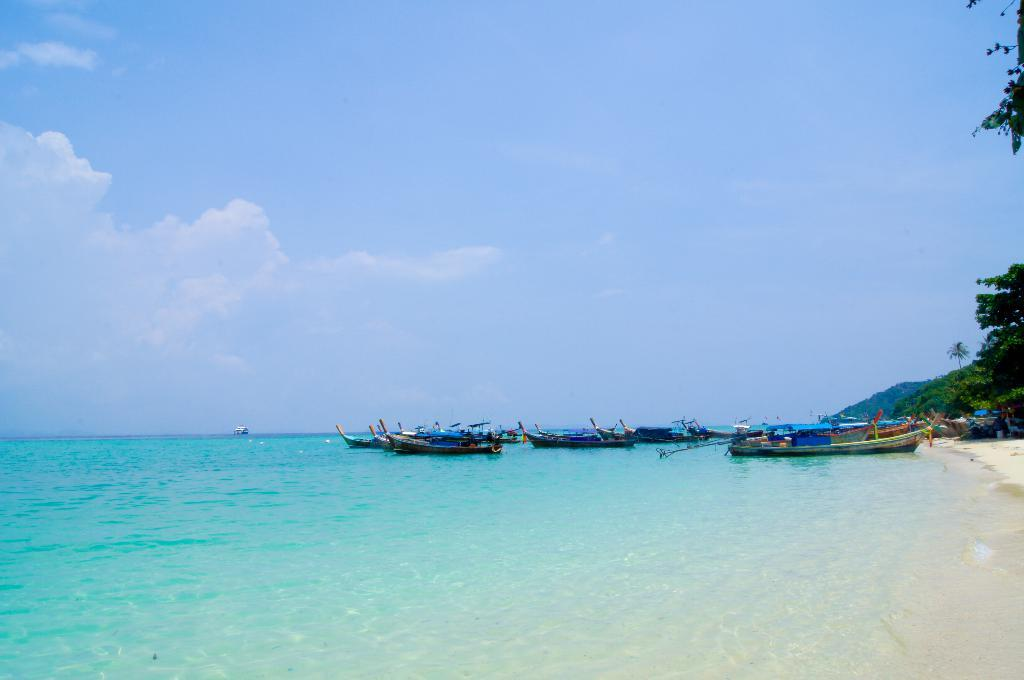What is the main feature of the image? There is a large water body in the image. What can be seen near the water body? There are boats on a sea shore in the image. What type of vegetation is visible in the background of the image? There is a group of trees visible in the background of the image. What other geographical feature can be seen in the background of the image? There is a hill visible in the background of the image. How would you describe the weather in the image? The sky appears cloudy in the image. What type of dress is the water wearing in the image? The water does not wear a dress, as it is a natural body of water and not a person. 